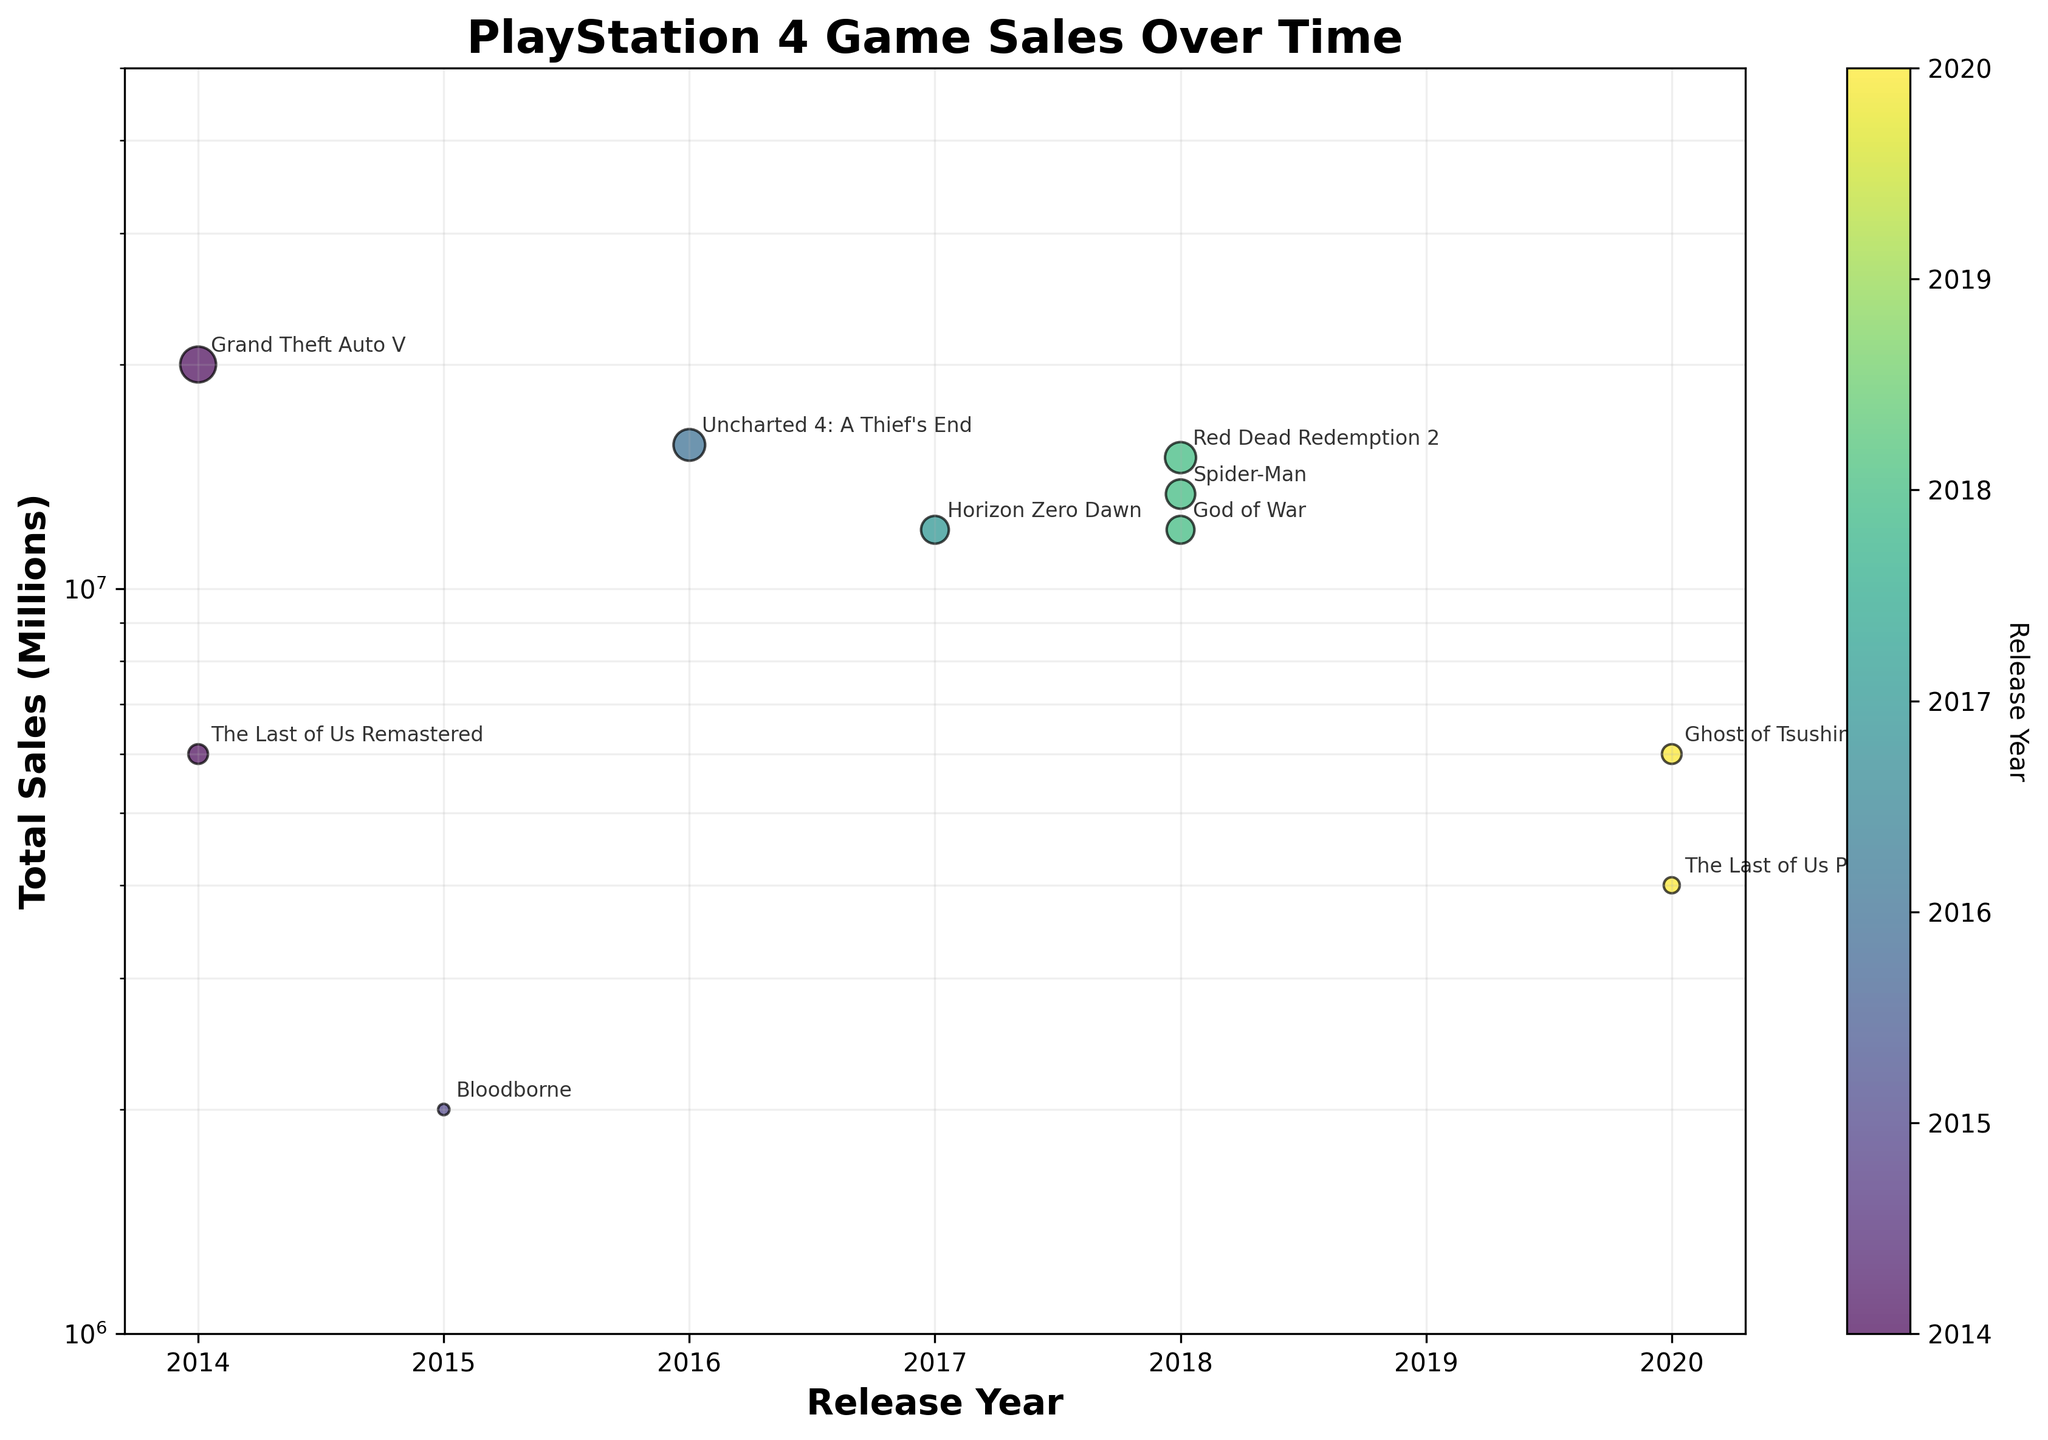What's the game with the highest sales figure? To find the game with the highest sales figure, look for the game with the highest y-coordinate on the plot, which is on a log scale for total sales. "Grand Theft Auto V" has the highest sales at 20 million.
Answer: Grand Theft Auto V How many games were released in 2018? To find the number of games released in 2018, look at the data points along the release year axis (x-axis). There are three data points corresponding to 2018. These games are "God of War," "Spider-Man," and "Red Dead Redemption 2."
Answer: 3 Which game released in 2020 had more sales, "The Last of Us Part II" or "Ghost of Tsushima"? "The Last of Us Part II" and "Ghost of Tsushima" are annotated on the figure at 2020. Compare their y-coordinates to determine which is higher. "Ghost of Tsushima" is higher on the y-axis, indicating it had higher sales at 6 million compared to "The Last of Us Part II"'s 4 million.
Answer: Ghost of Tsushima On a log scale, what is the approximate sales figure for "Bloodborne"? Locate "Bloodborne" on the plot. The y-coordinate for "Bloodborne" is slightly above 2 million. Since the axis is on a log scale, this small displacement is amplified, corresponding to an actual value of 2 million.
Answer: 2 million What is the median sales figure for all the games shown in the plot? First, list all the total sales figures in ascending order: 2 million, 4 million, 6 million (twice), 12 million (twice), 13.4 million, 15 million, 15.6 million, and 20 million. The median is the middle value: (12 million + 12 million)/2 = 12 million.
Answer: 12 million Which game released in 2018 had the highest sales, and what was that figure? Examine the games released in 2018: "God of War," "Spider-Man," and "Red Dead Redemption 2." Among these, "Red Dead Redemption 2" has the highest sales figure of 15 million.
Answer: Red Dead Redemption 2, 15 million Are the sales for "The Last of Us Remastered" and "Ghost of Tsushima" approximately the same? Compare the two data points for "The Last of Us Remastered" and "Ghost of Tsushima." Both points lie on the same y-coordinate at 6 million, indicating their sales are approximately the same.
Answer: Yes What is the range of years during which these games were released? Identify the first and last years labeled on the x-axis, which represent the release years of the games. The games range from 2014 to 2020.
Answer: 2014 to 2020 